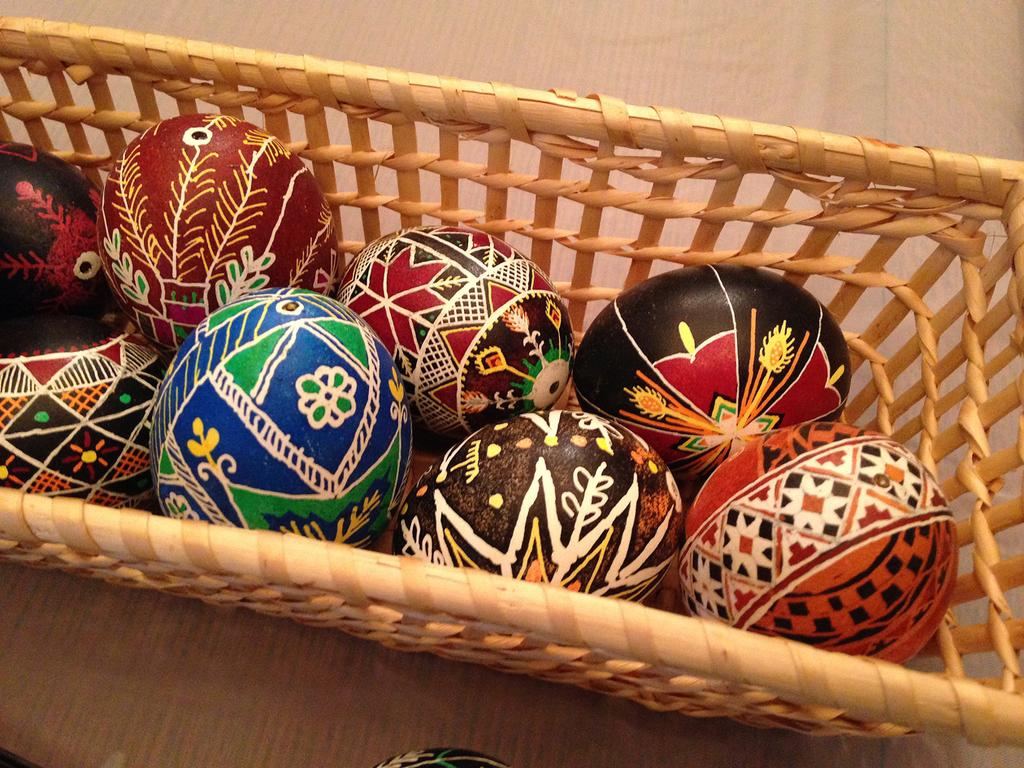What is present on some of the objects in the image? There are paintings on some objects. Where are the objects with paintings located? The objects with paintings are in a basket. How many legs can be seen on the donkey in the image? There is no donkey present in the image, so it is not possible to determine the number of legs. 